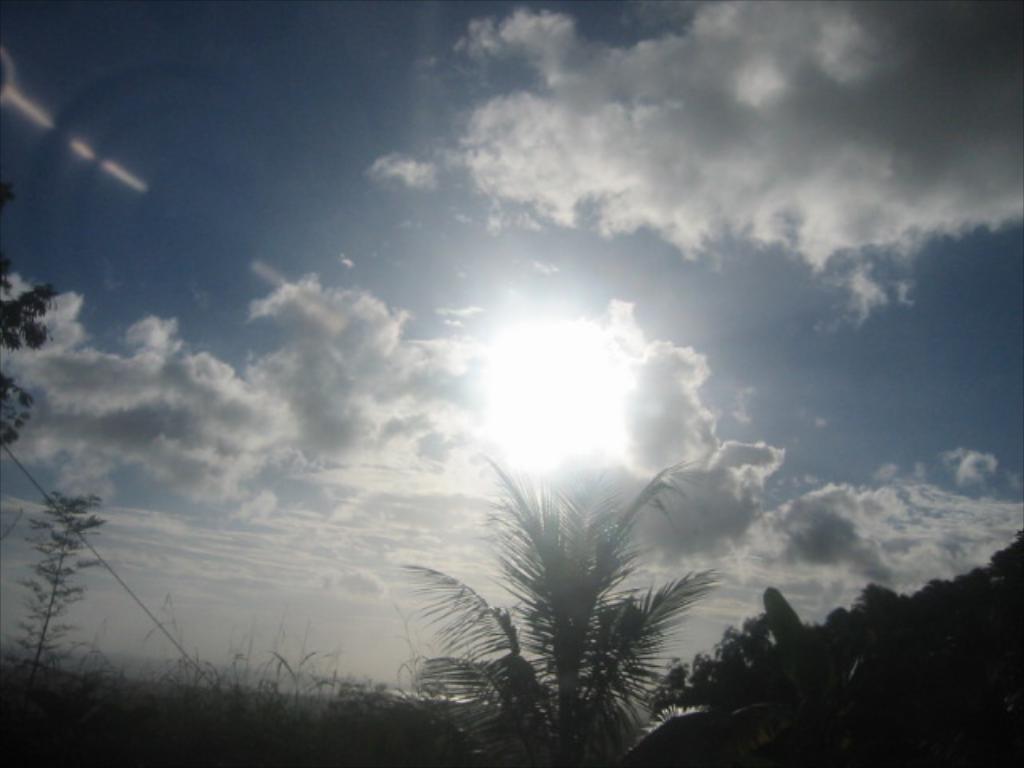Describe this image in one or two sentences. In this image I see the plants and the trees. In the background I see the sky which is of white and blue in color and I see that it is a bit cloudy and I see the sun over here. 